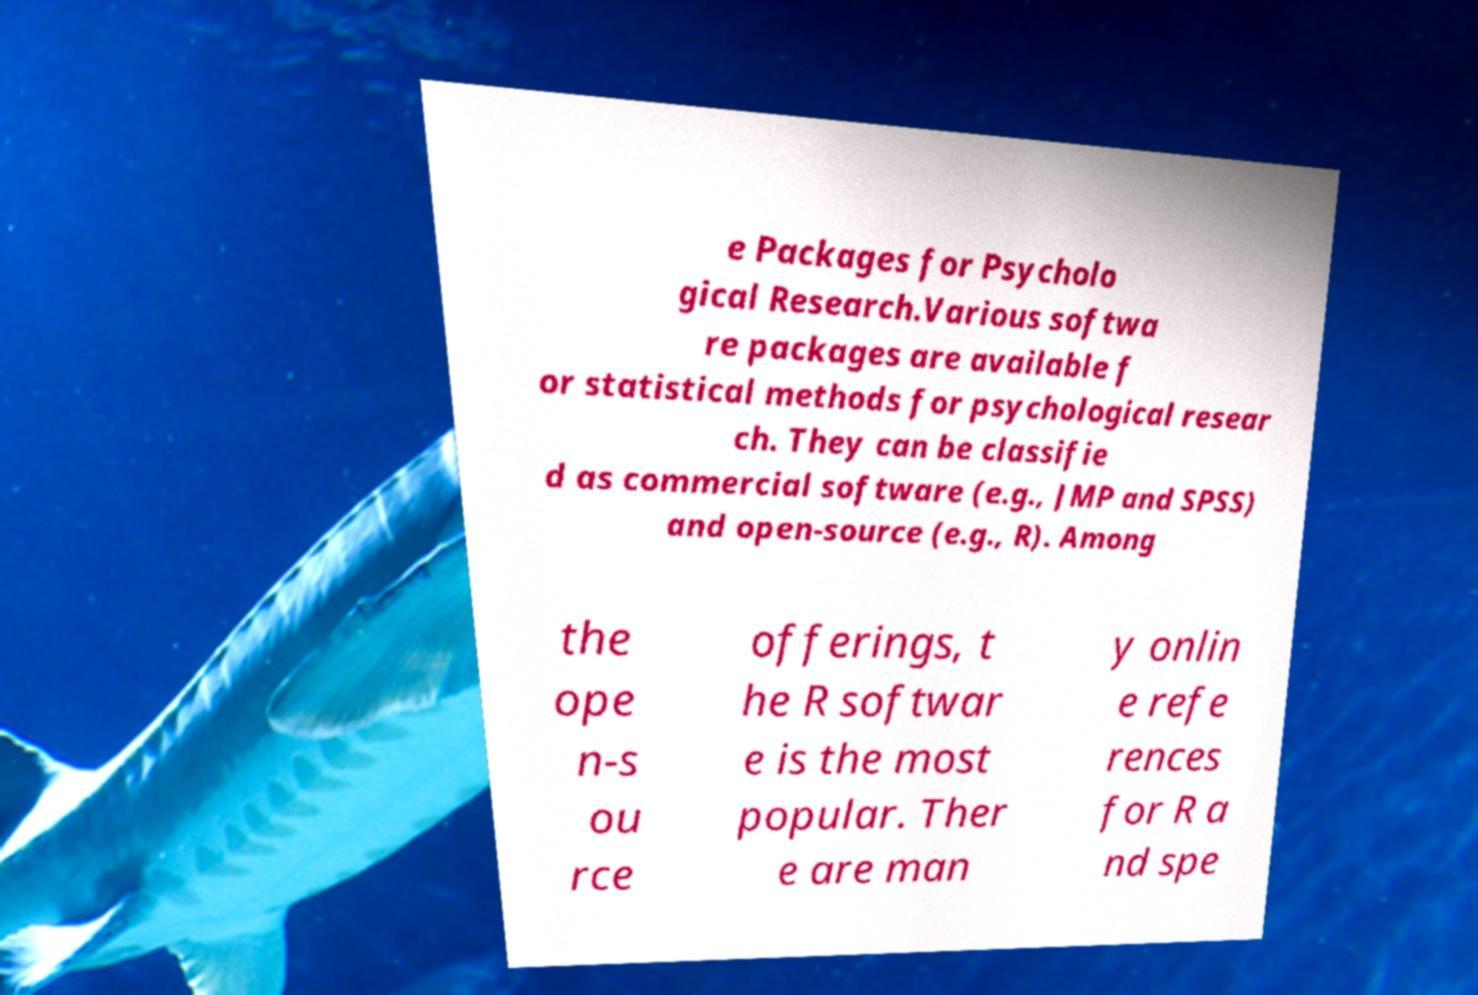Can you accurately transcribe the text from the provided image for me? e Packages for Psycholo gical Research.Various softwa re packages are available f or statistical methods for psychological resear ch. They can be classifie d as commercial software (e.g., JMP and SPSS) and open-source (e.g., R). Among the ope n-s ou rce offerings, t he R softwar e is the most popular. Ther e are man y onlin e refe rences for R a nd spe 